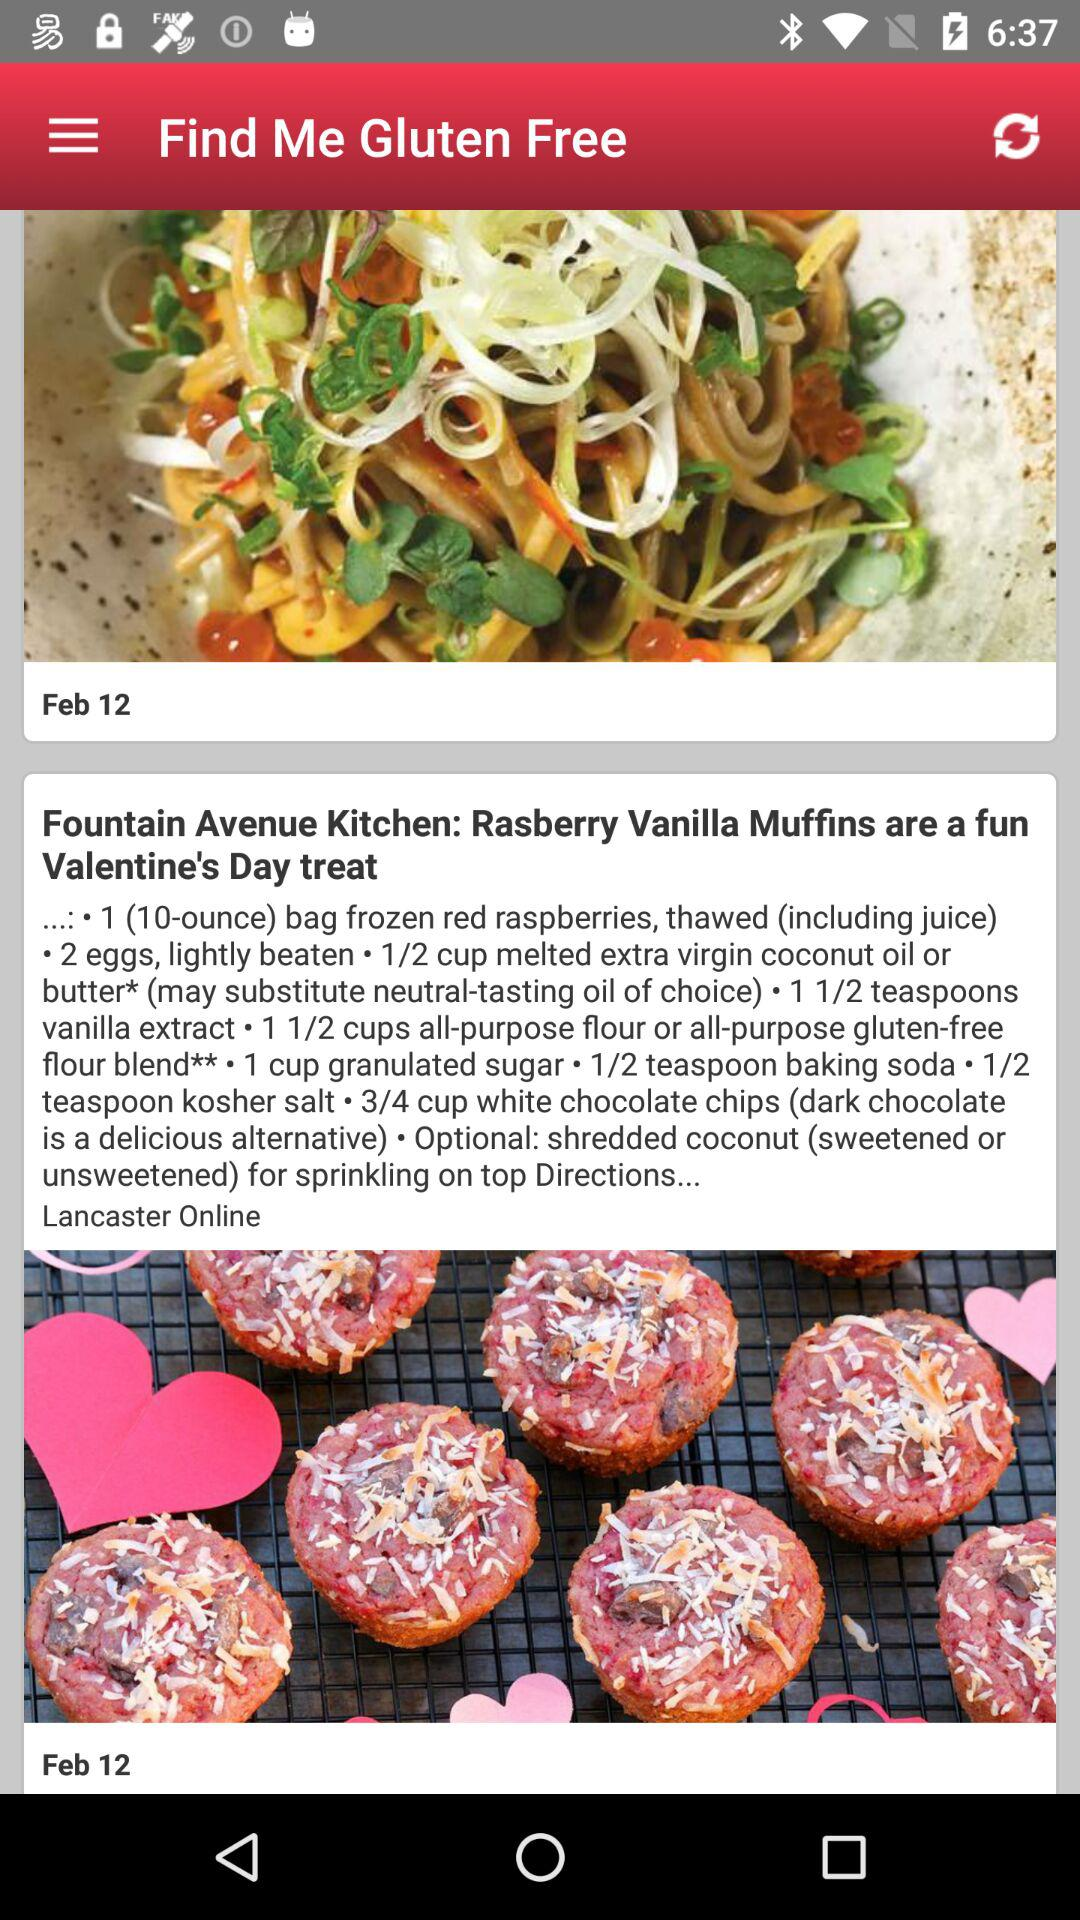What is the given date? The given date is February 12. 